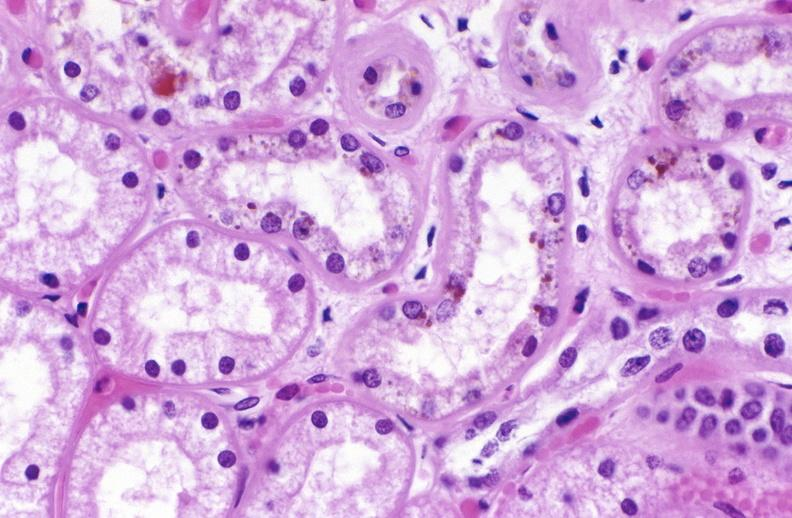s cardiovascular present?
Answer the question using a single word or phrase. No 